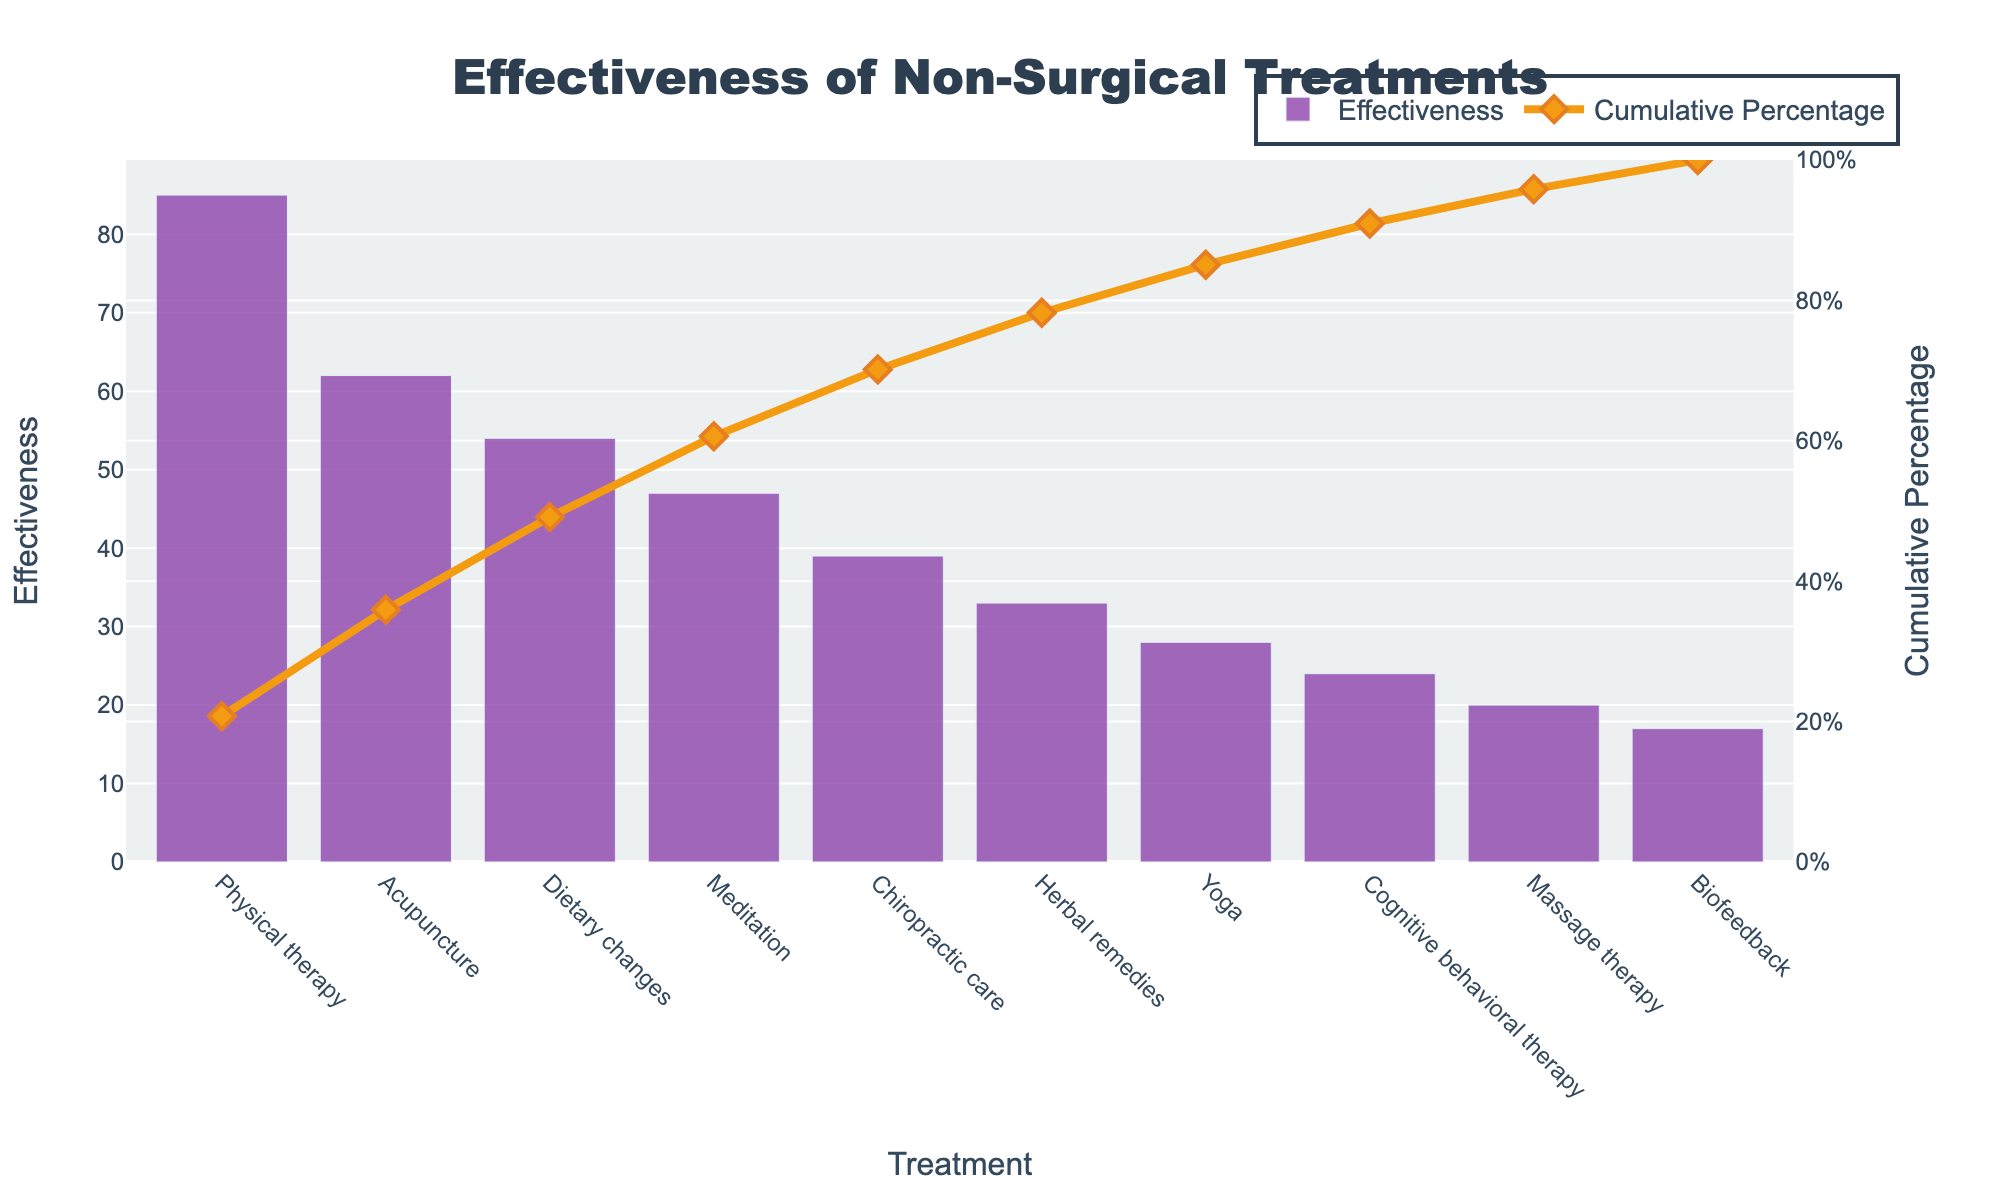What is the most effective non-surgical treatment? The bar chart shows that Physical therapy has the highest bar, indicating its percentage of effectiveness is the highest.
Answer: Physical therapy What is the cumulative percentage of effectiveness for the top three treatments? According to the cumulative percentage line, you sum up the percentages of Physical therapy, Acupuncture, and Dietary changes: 85 + 62 + 54 = 201. Divide by the sum of all effectiveness values (410) and multiply by 100: (201/410)*100 ≈ 49%.
Answer: 49% Which treatment ranks just above Chiropractic care in effectiveness? In the sorted effectiveness chart, the effectiveness of Chiropractic care is right below Meditation.
Answer: Meditation How much more effective is Physical therapy compared to Massage therapy? Subtract the effectiveness of Massage therapy (20) from the effectiveness of Physical therapy (85): 85 - 20 = 65.
Answer: 65 What is the title of the chart? The title is displayed at the top of the chart, it reads “Effectiveness of Non-Surgical Treatments”.
Answer: Effectiveness of Non-Surgical Treatments What is the cumulative effectiveness percentage for Yoga? Find Yoga on the x-axis and look at the cumulative percentage line above it. It touches approximately 91%.
Answer: 91% How many treatments have an effectiveness below 30%? The chart shows four bars (Yoga, Cognitive behavioral therapy, Massage therapy, Biofeedback) have heights below the 30% mark on the y-axis.
Answer: Four Which has the least effectiveness and what is its cumulative percentage? Biofeedback, at the far right of the chart, has the smallest bar. The cumulative line above it is approximately at 100%.
Answer: Biofeedback, 100% What is the effectiveness value of Herbal remedies, and how does it relate to its cumulative percentage? The height of the Herbal remedies bar corresponds to an effectiveness of 33, and the cumulative percentage above it shows roughly 75%.
Answer: 33, 75% How does the color of the bars differ from the line and markers? The bars are colored with a shade of purple, while the cumulative line and markers are orange and diamond-shaped.
Answer: Purple, Orange 